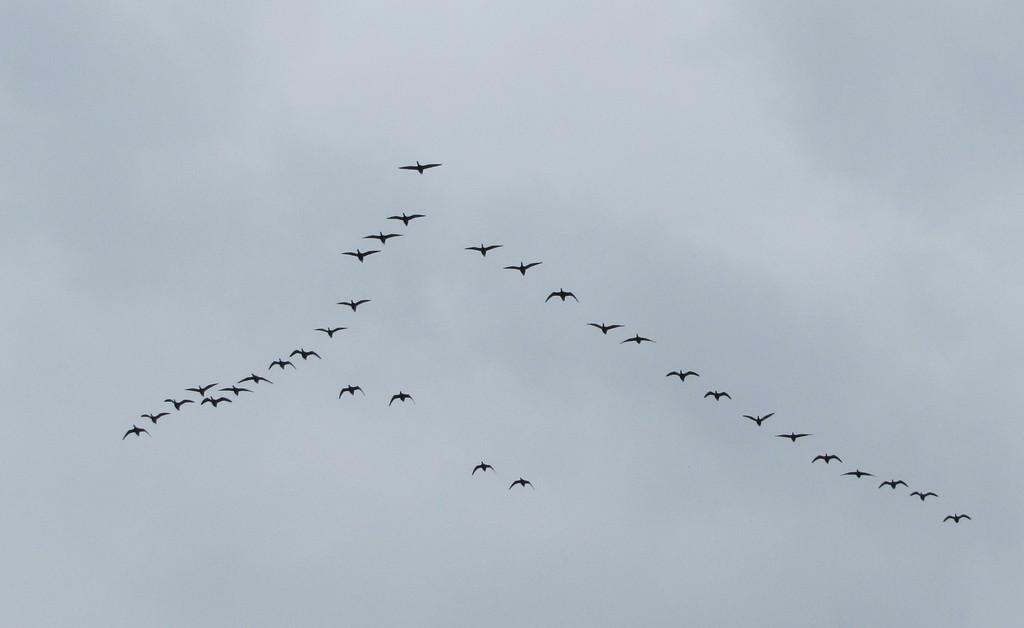What type of animals can be seen in the image? There are birds in the image. What color are the birds? The birds are black in color. What is visible in the background of the image? The background of the image is the sky. What color is the sky in the image? The sky is white in color. Where are the bushes located in the image? There are no bushes present in the image; it features black birds against a white sky. What type of jewel can be seen on the bird's neck in the image? There are no jewels present on the birds in the image; they are simply black birds against a white sky. 